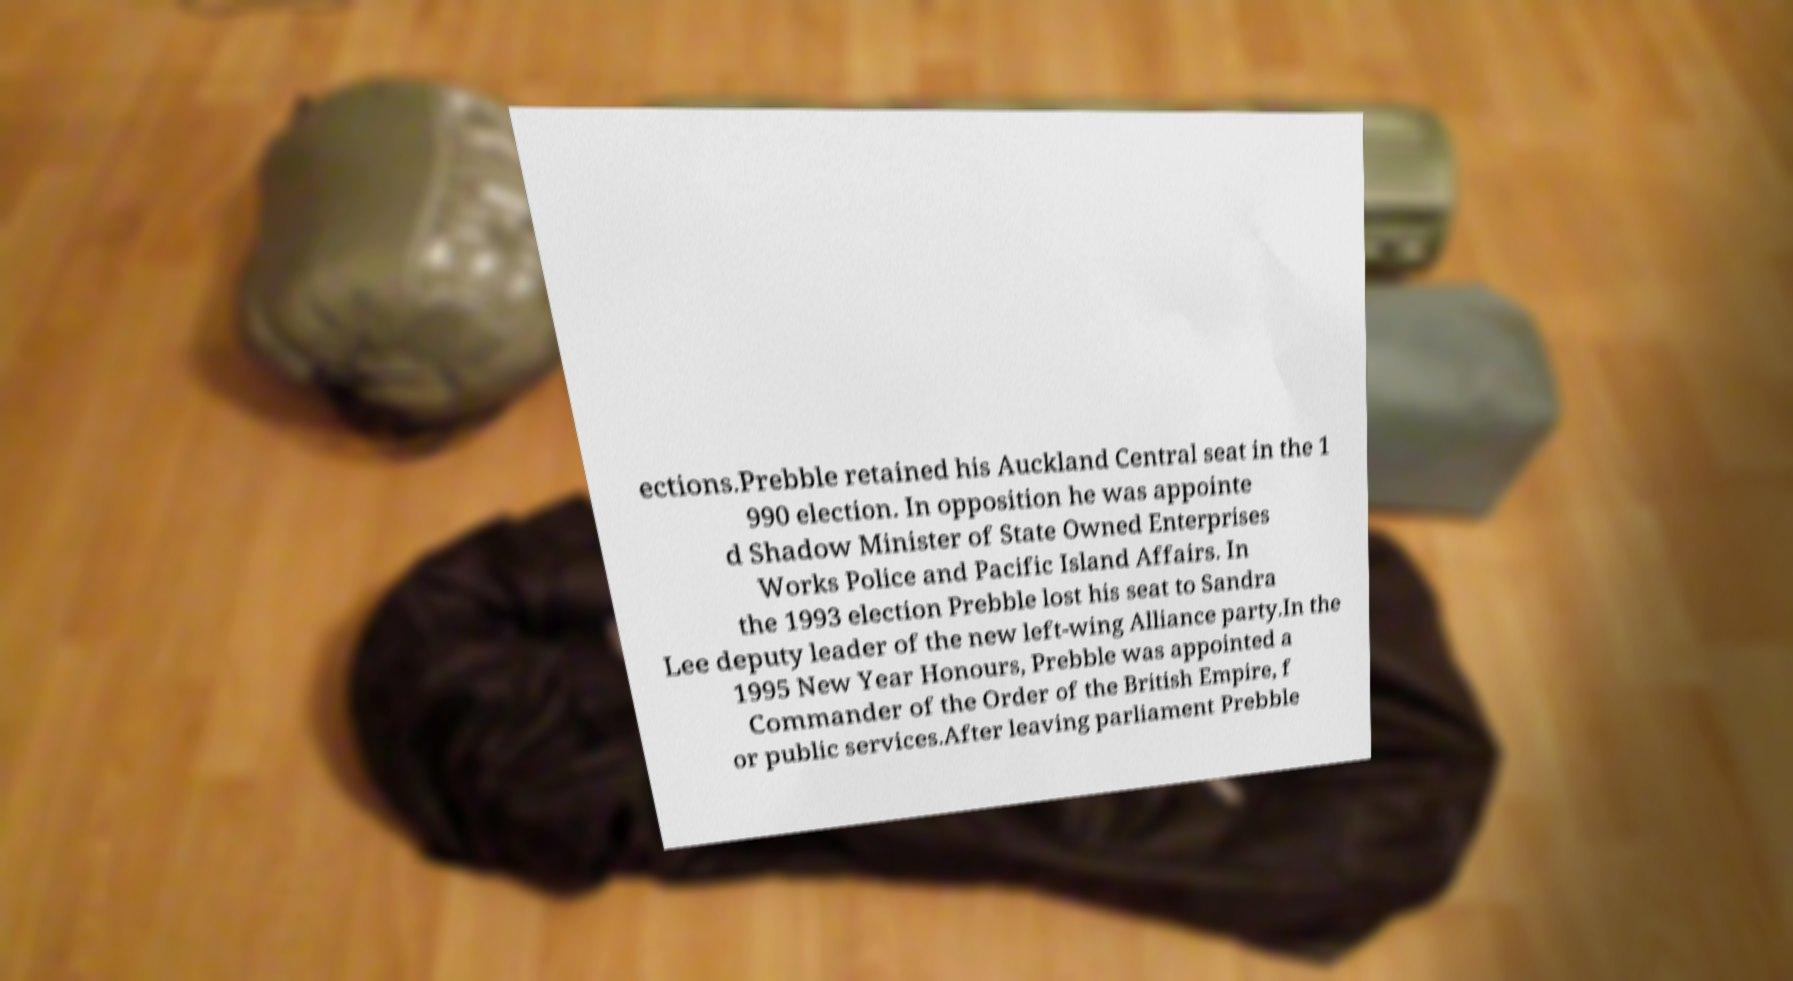What messages or text are displayed in this image? I need them in a readable, typed format. ections.Prebble retained his Auckland Central seat in the 1 990 election. In opposition he was appointe d Shadow Minister of State Owned Enterprises Works Police and Pacific Island Affairs. In the 1993 election Prebble lost his seat to Sandra Lee deputy leader of the new left-wing Alliance party.In the 1995 New Year Honours, Prebble was appointed a Commander of the Order of the British Empire, f or public services.After leaving parliament Prebble 